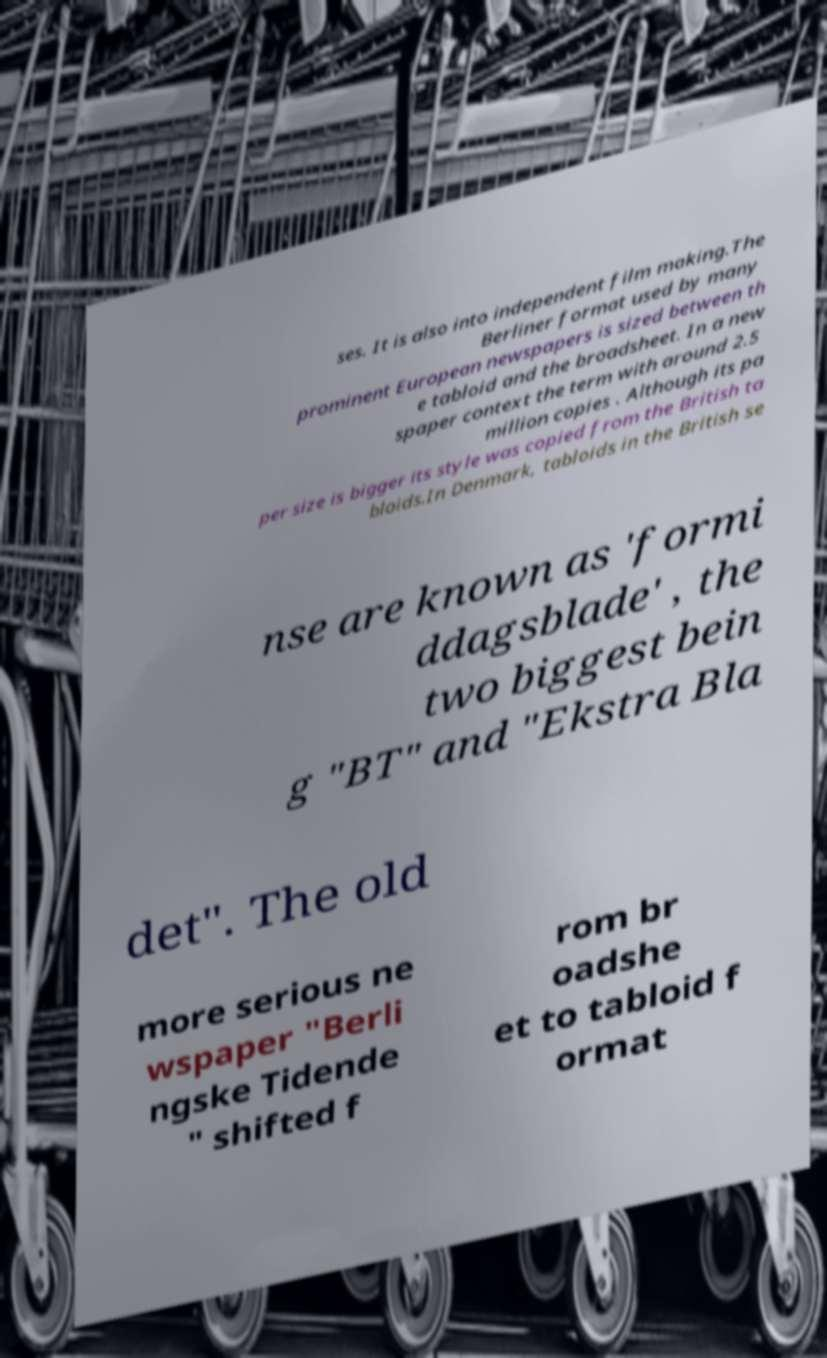What messages or text are displayed in this image? I need them in a readable, typed format. ses. It is also into independent film making.The Berliner format used by many prominent European newspapers is sized between th e tabloid and the broadsheet. In a new spaper context the term with around 2.5 million copies . Although its pa per size is bigger its style was copied from the British ta bloids.In Denmark, tabloids in the British se nse are known as 'formi ddagsblade' , the two biggest bein g "BT" and "Ekstra Bla det". The old more serious ne wspaper "Berli ngske Tidende " shifted f rom br oadshe et to tabloid f ormat 